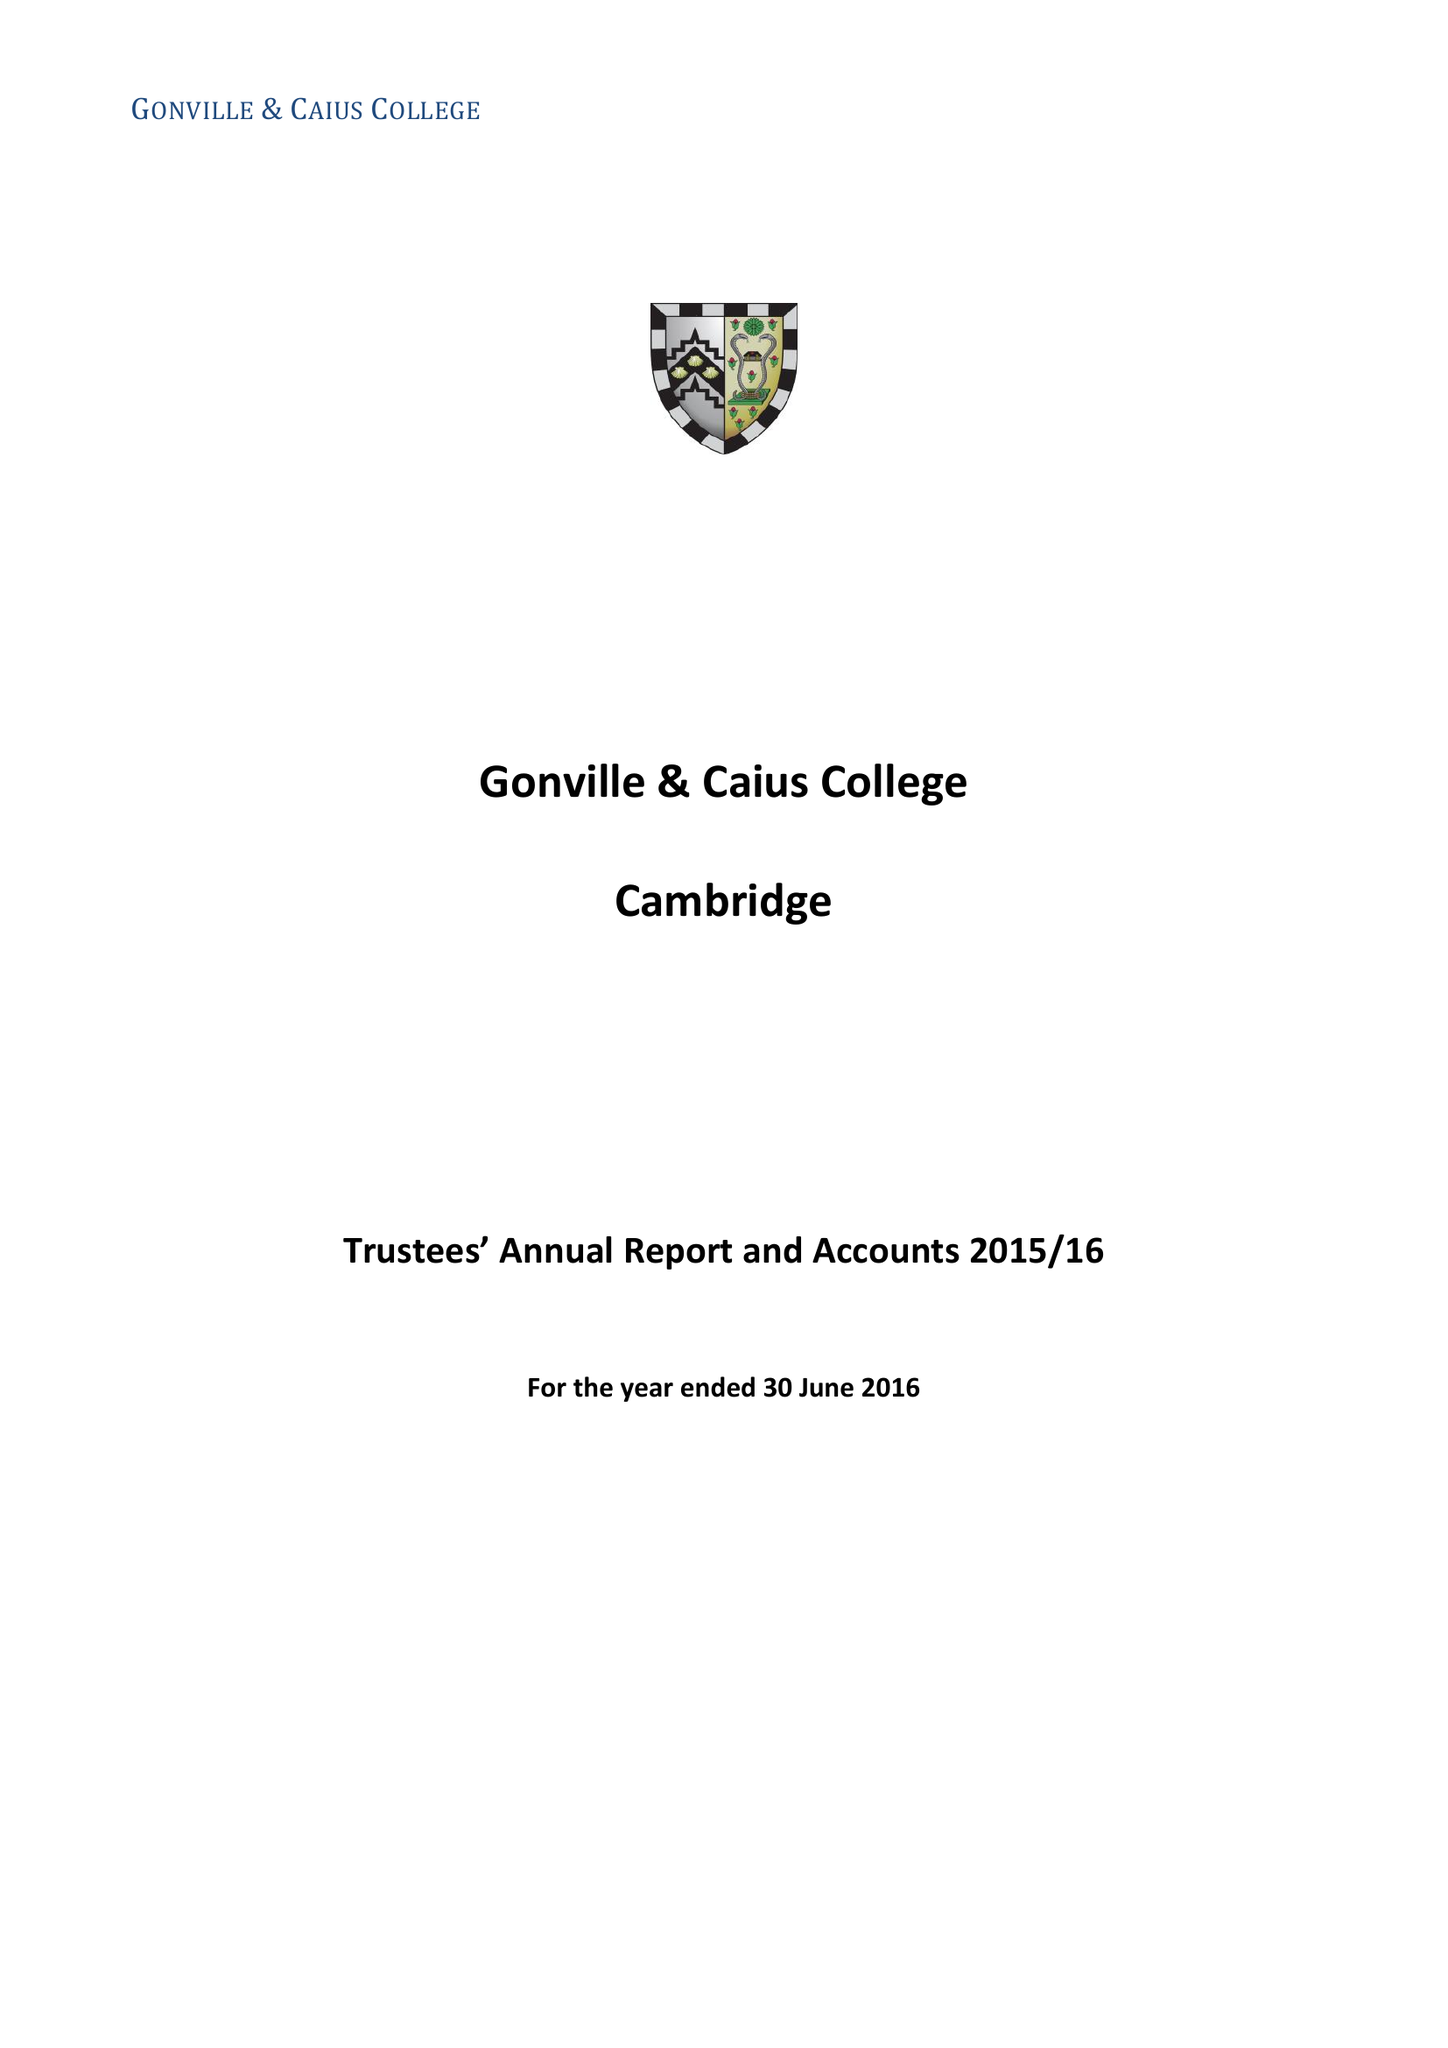What is the value for the address__street_line?
Answer the question using a single word or phrase. TRINITY STREET 